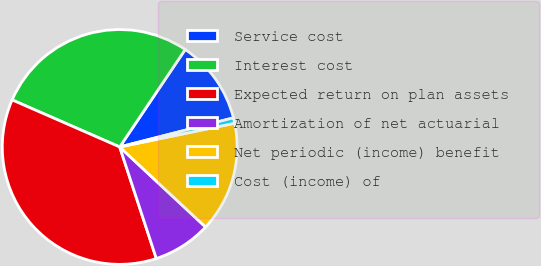Convert chart to OTSL. <chart><loc_0><loc_0><loc_500><loc_500><pie_chart><fcel>Service cost<fcel>Interest cost<fcel>Expected return on plan assets<fcel>Amortization of net actuarial<fcel>Net periodic (income) benefit<fcel>Cost (income) of<nl><fcel>11.59%<fcel>27.86%<fcel>36.61%<fcel>8.01%<fcel>15.18%<fcel>0.75%<nl></chart> 